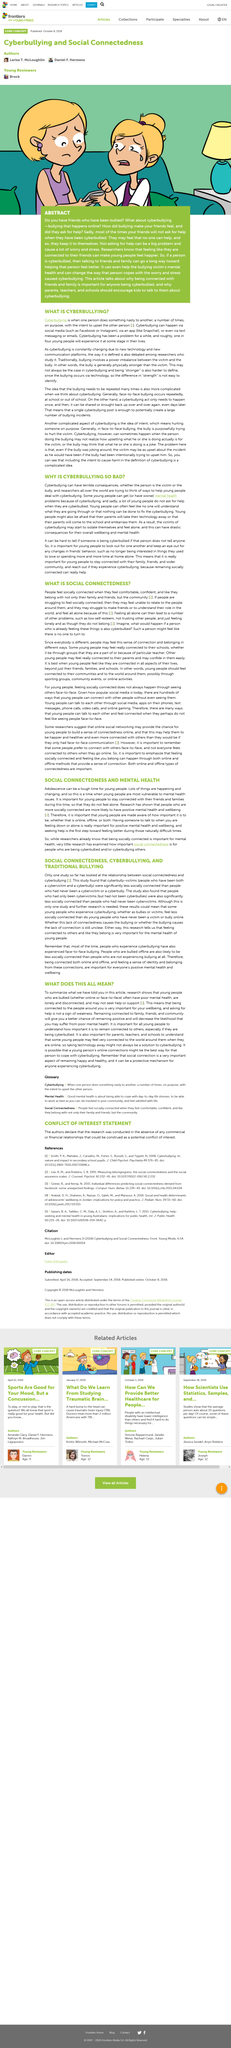List a handful of essential elements in this visual. When people feel comfortable, they generally feel socially connected. Cyberbullying is a behavior where one person deliberately harms another person through the use of digital technology, including social media, text messaging, and the internet. Seeking help is the first step toward feeling better during naturally difficult times. When individuals feel socially isolated and disconnected, they may experience difficulties forming meaningful relationships with others, understanding their place in the world, and feeling a sense of belonging. Yes, Facebook is an example of social media. 